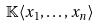Convert formula to latex. <formula><loc_0><loc_0><loc_500><loc_500>\mathbb { K } \langle x _ { 1 } , \dots , x _ { n } \rangle</formula> 